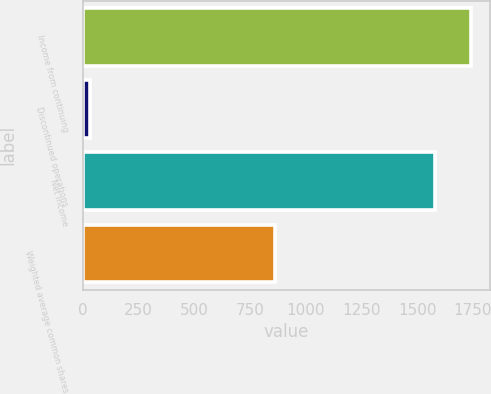Convert chart. <chart><loc_0><loc_0><loc_500><loc_500><bar_chart><fcel>Income from continuing<fcel>Discontinued operations<fcel>Net income<fcel>Weighted average common shares<nl><fcel>1740.2<fcel>31<fcel>1582<fcel>864.2<nl></chart> 